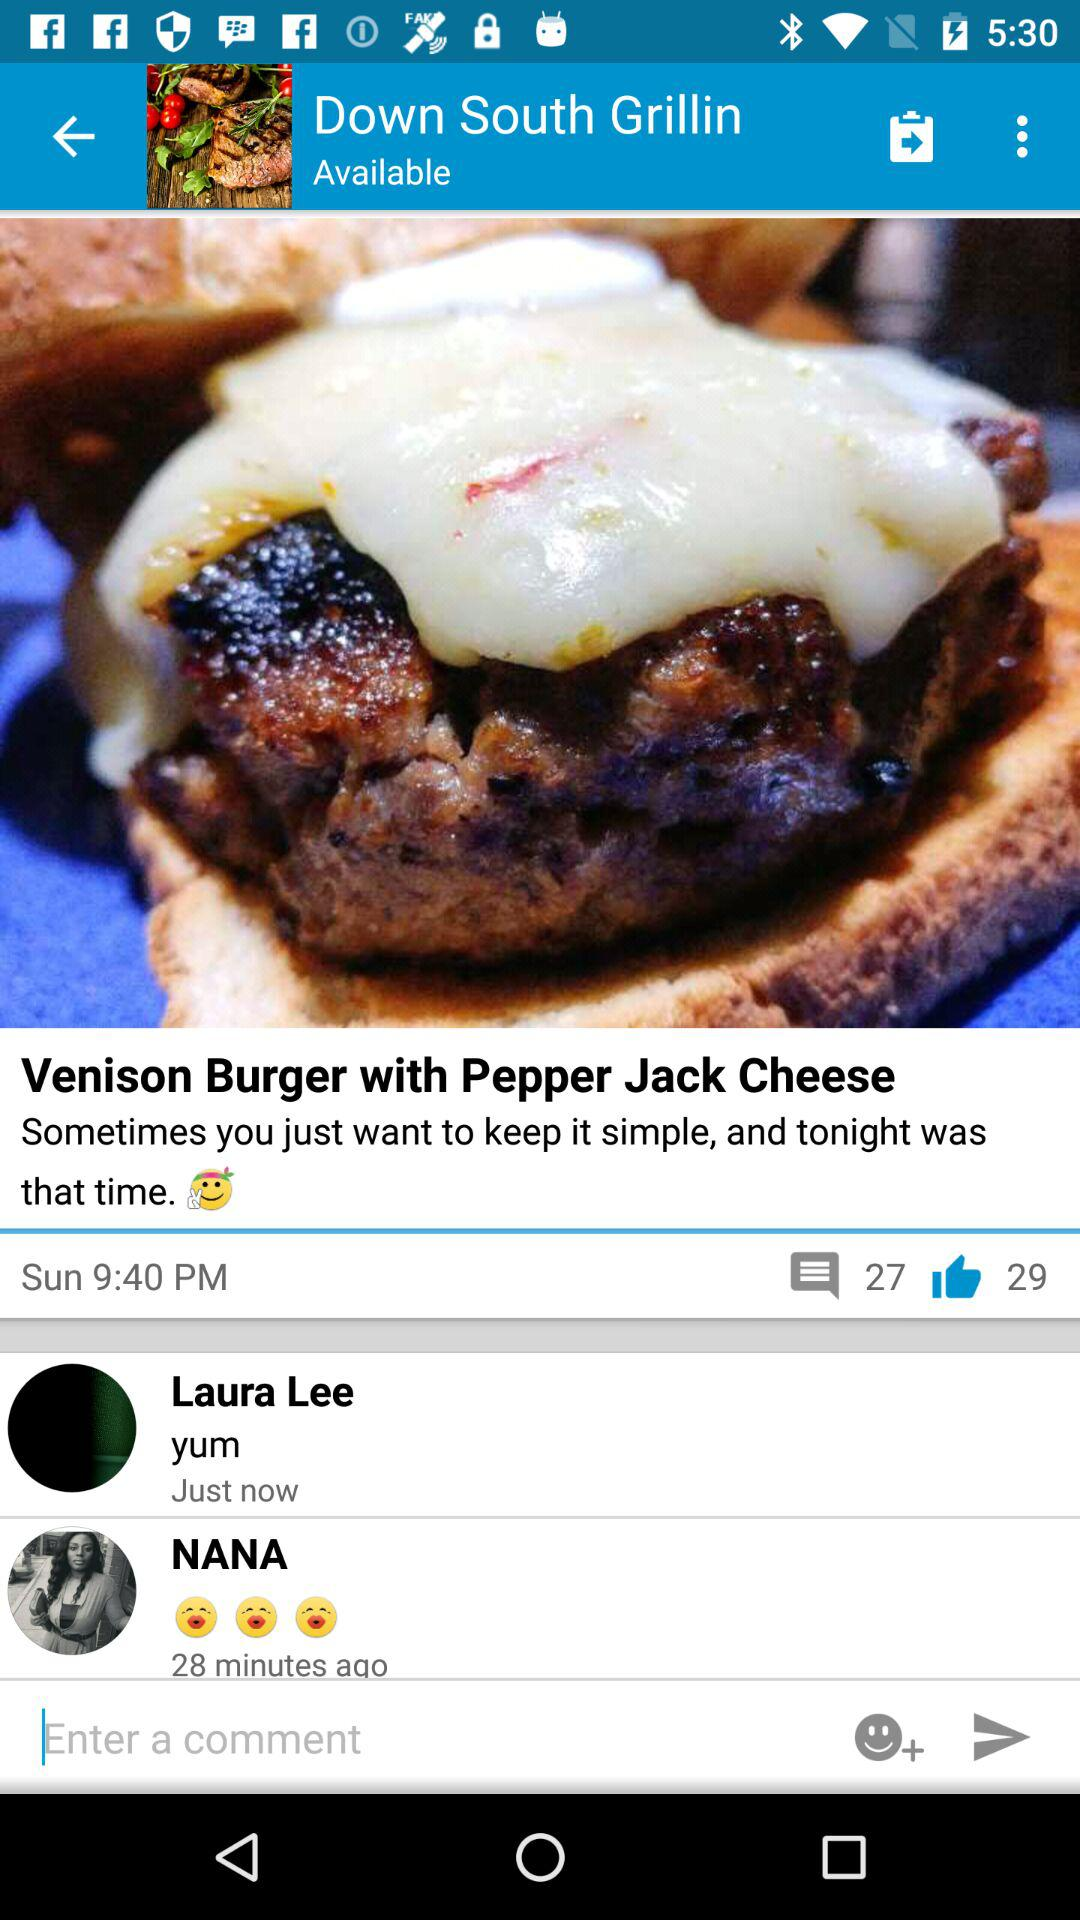Who has just commented on the post "Venison Burger with Pepper Jack Cheese"? The person who just commented on the post "Venison Burger with Pepper Jack Cheese" is Laura Lee. 